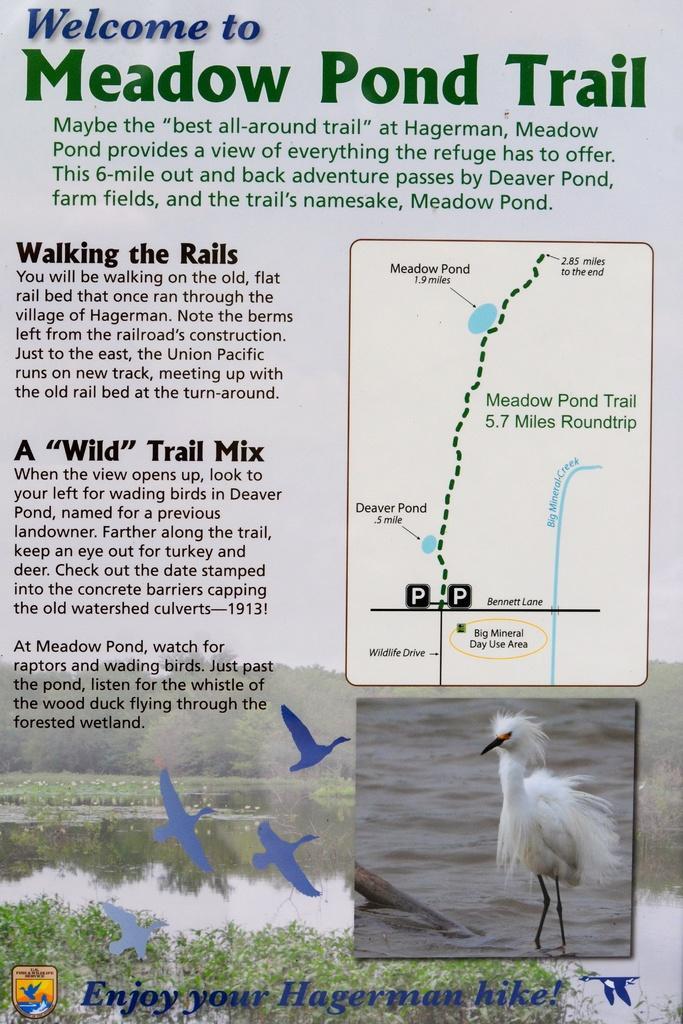Please provide a concise description of this image. In the image we can see there is a poster on which a bird is standing in the water. Beside there is a matter about the bird and on the top there is a route map. 